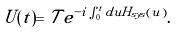<formula> <loc_0><loc_0><loc_500><loc_500>U ( t ) = \mathcal { T } e ^ { - i \int _ { 0 } ^ { t } d u H _ { s y s } ( u ) } .</formula> 